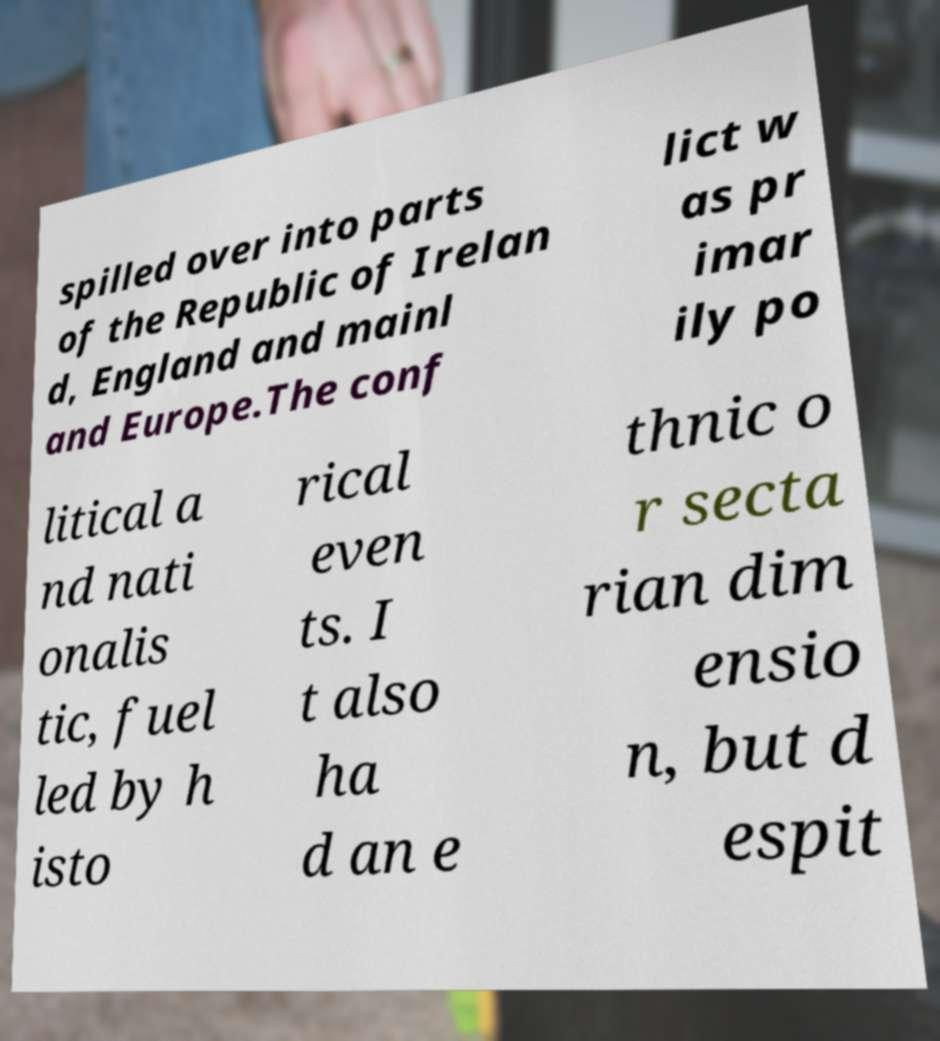Could you assist in decoding the text presented in this image and type it out clearly? spilled over into parts of the Republic of Irelan d, England and mainl and Europe.The conf lict w as pr imar ily po litical a nd nati onalis tic, fuel led by h isto rical even ts. I t also ha d an e thnic o r secta rian dim ensio n, but d espit 